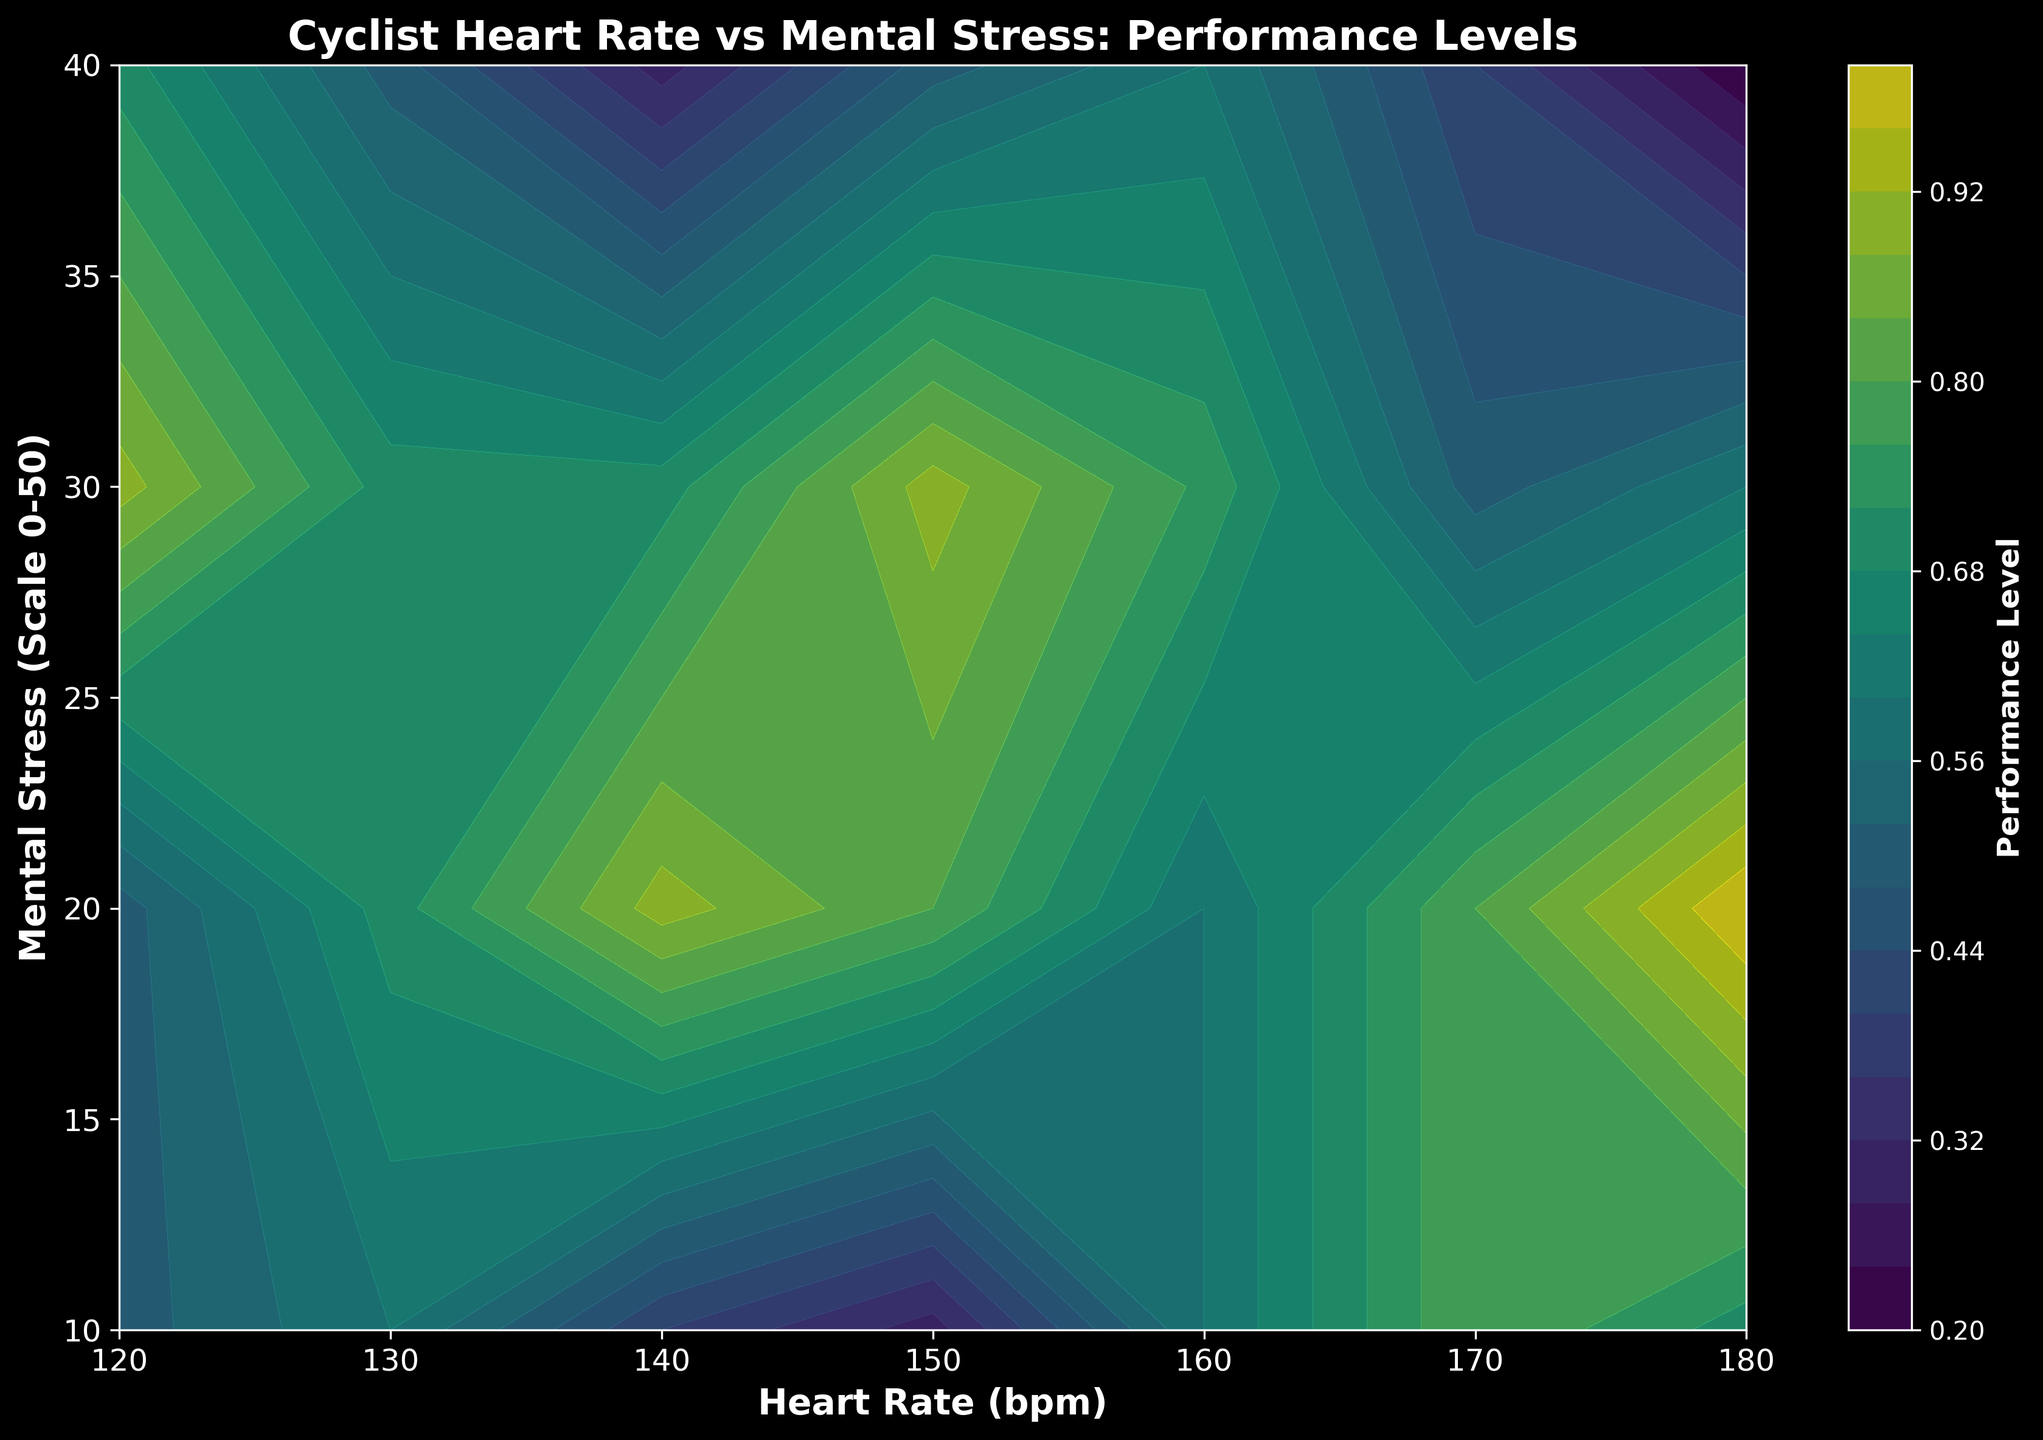What is the heart rate and mental stress level where the performance is highest? The highest performance value is 1.0, which occurs at a heart rate of 150 bpm and a mental stress level of 20. By looking at the plotted grid, we find the highest point's coordinates in these axes.
Answer: 150 bpm and 20 How does performance change as heart rate increases from 120 bpm to 180 bpm at a mental stress level of 20? At 20 mental stress level, the performance starts at 0.6 for 120 bpm, increases to 1.0 at 150 bpm, and then decreases to 0.6 at 180 bpm. This indicates an initial increase in performance with increasing heart rate up to 150 bpm, followed by a decrease after that point.
Answer: Initially increases then decreases What is the predominant color corresponding to the highest performance levels on the plot? The highest performance levels, indicated by the value 1.0, are represented by the color at the top end of the 'viridis' color scale. Observing the plot, this corresponds to a bright yellowish-green color.
Answer: Bright yellowish-green At what range of heart rates does the performance peak when the mental stress level is 30? At a mental stress level of 30, the performance peaks (value of 0.9) around a heart rate of 150 bpm, referring to the contour plot and matching colors.
Answer: Around 150 bpm How does performance change as mental stress increases from 10 to 40 at a heart rate of 160 bpm? At 160 bpm, the performance starts from 0.7 at mental stress level 10, peaks at 0.9 at level 20, declines to 0.75 at level 30, and drops further to 0.5 at level 40. Thus, performance first increases and then decreases.
Answer: Increases then decreases Compare performance at a heart rate of 140 bpm between mental stress levels of 10 and 40. At 140 bpm, the performance at a mental stress level of 10 is 0.7, while at a mental stress level of 40 it drops to 0.6. By comparing these values, we see that performance is higher at the lower stress level.
Answer: Higher at 10 mental stress What is the median performance value for heart rates between 130 bpm and 170 bpm at a mental stress level of 20? Considering heart rates 130, 140, 150, 160, and 170 bpm at 20 mental stress level, the performance values are 0.8, 0.9, 1.0, 0.9, and 0.7. Sorting these values (0.7, 0.8, 0.9, 0.9, 1.0), the median value is the middle one, which is 0.9.
Answer: 0.9 Which combination of heart rate and mental stress shows the lowest performance? By checking the plot, the lowest performance (0.2) occurs at a heart rate of 180 bpm and a mental stress level of 40. These coordinates are verified by finding the darkest color in the contour plot for performance.
Answer: 180 bpm and 40 How does performance at a heart rate of 150 bpm compare between mental stress levels of 10 and 30? At 150 bpm, the performance at 10 mental stress is 0.8, while at 30 mental stress it is 0.9. Comparing these values shows that performance is higher at 30 mental stress.
Answer: Higher at 30 mental stress What range of mental stress levels is associated with an optimal performance zone (greater than 0.8) for a flat heart rate of 150 bpm? For a heart rate of 150 bpm, the performance values greater than 0.8 occur between mental stress levels 10, 20, and 30. Thus, the optimal performance zone for this heart rate covers these stress levels.
Answer: 10 to 30 